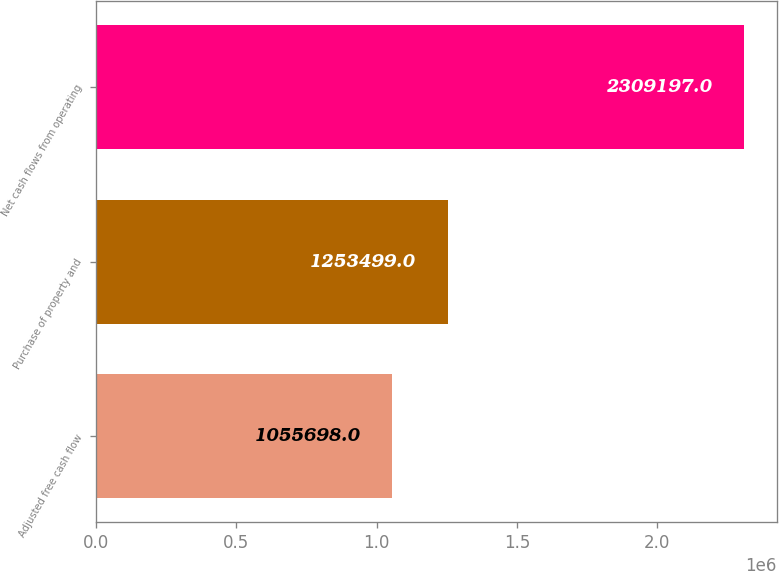<chart> <loc_0><loc_0><loc_500><loc_500><bar_chart><fcel>Adjusted free cash flow<fcel>Purchase of property and<fcel>Net cash flows from operating<nl><fcel>1.0557e+06<fcel>1.2535e+06<fcel>2.3092e+06<nl></chart> 